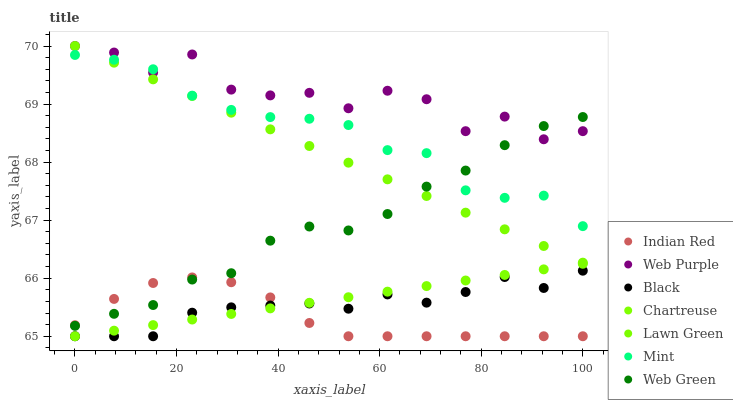Does Indian Red have the minimum area under the curve?
Answer yes or no. Yes. Does Web Purple have the maximum area under the curve?
Answer yes or no. Yes. Does Chartreuse have the minimum area under the curve?
Answer yes or no. No. Does Chartreuse have the maximum area under the curve?
Answer yes or no. No. Is Chartreuse the smoothest?
Answer yes or no. Yes. Is Web Purple the roughest?
Answer yes or no. Yes. Is Web Green the smoothest?
Answer yes or no. No. Is Web Green the roughest?
Answer yes or no. No. Does Chartreuse have the lowest value?
Answer yes or no. Yes. Does Web Green have the lowest value?
Answer yes or no. No. Does Web Purple have the highest value?
Answer yes or no. Yes. Does Chartreuse have the highest value?
Answer yes or no. No. Is Indian Red less than Mint?
Answer yes or no. Yes. Is Web Green greater than Black?
Answer yes or no. Yes. Does Web Purple intersect Web Green?
Answer yes or no. Yes. Is Web Purple less than Web Green?
Answer yes or no. No. Is Web Purple greater than Web Green?
Answer yes or no. No. Does Indian Red intersect Mint?
Answer yes or no. No. 